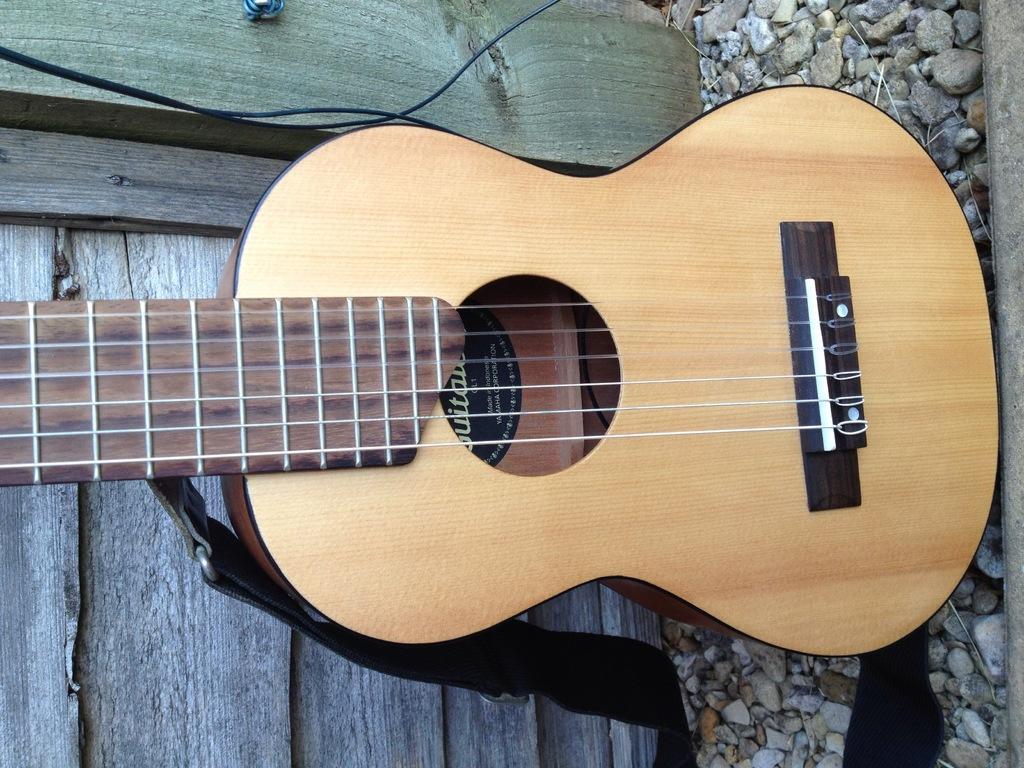Could you give a brief overview of what you see in this image? In this image I can see a guitar and the stones. 